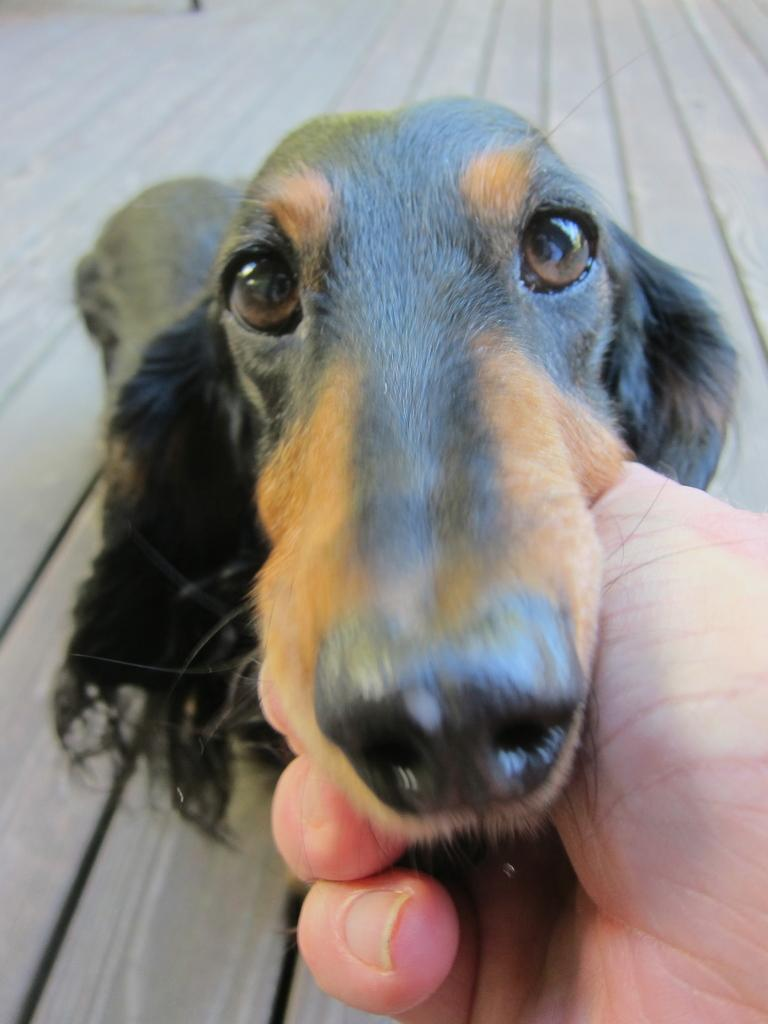What is the main subject of the image? There is a person in the image. What is the person doing in the image? The person's hand is holding a dog. Where is the dog located in the image? The dog is in the middle of the image. What can be seen in the background of the image? There is a wooden surface in the background of the image. What type of property is being celebrated in the image? There is no indication of a property or celebration in the image; it features a person holding a dog. 